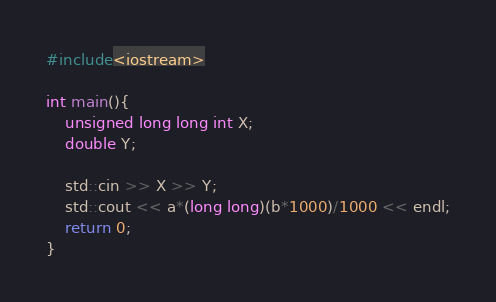<code> <loc_0><loc_0><loc_500><loc_500><_C++_>#include<iostream>
 
int main(){
    unsigned long long int X;
    double Y;

    std::cin >> X >> Y;
    std::cout << a*(long long)(b*1000)/1000 << endl;
    return 0;
}</code> 